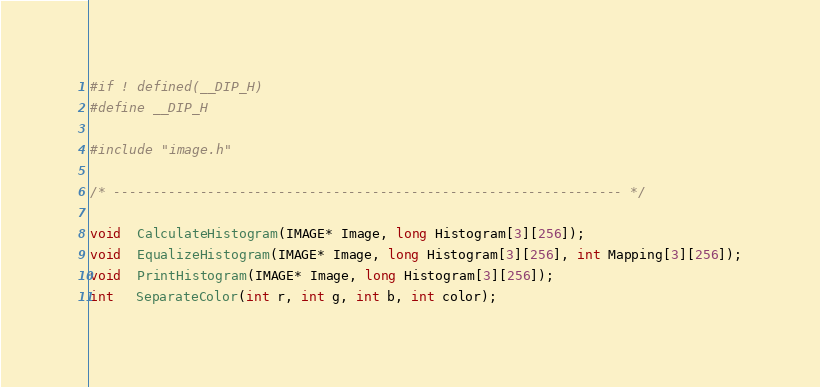<code> <loc_0><loc_0><loc_500><loc_500><_C_>#if ! defined(__DIP_H)
#define __DIP_H

#include "image.h"

/* ----------------------------------------------------------------- */

void  CalculateHistogram(IMAGE* Image, long Histogram[3][256]);
void  EqualizeHistogram(IMAGE* Image, long Histogram[3][256], int Mapping[3][256]);
void  PrintHistogram(IMAGE* Image, long Histogram[3][256]);
int   SeparateColor(int r, int g, int b, int color);</code> 